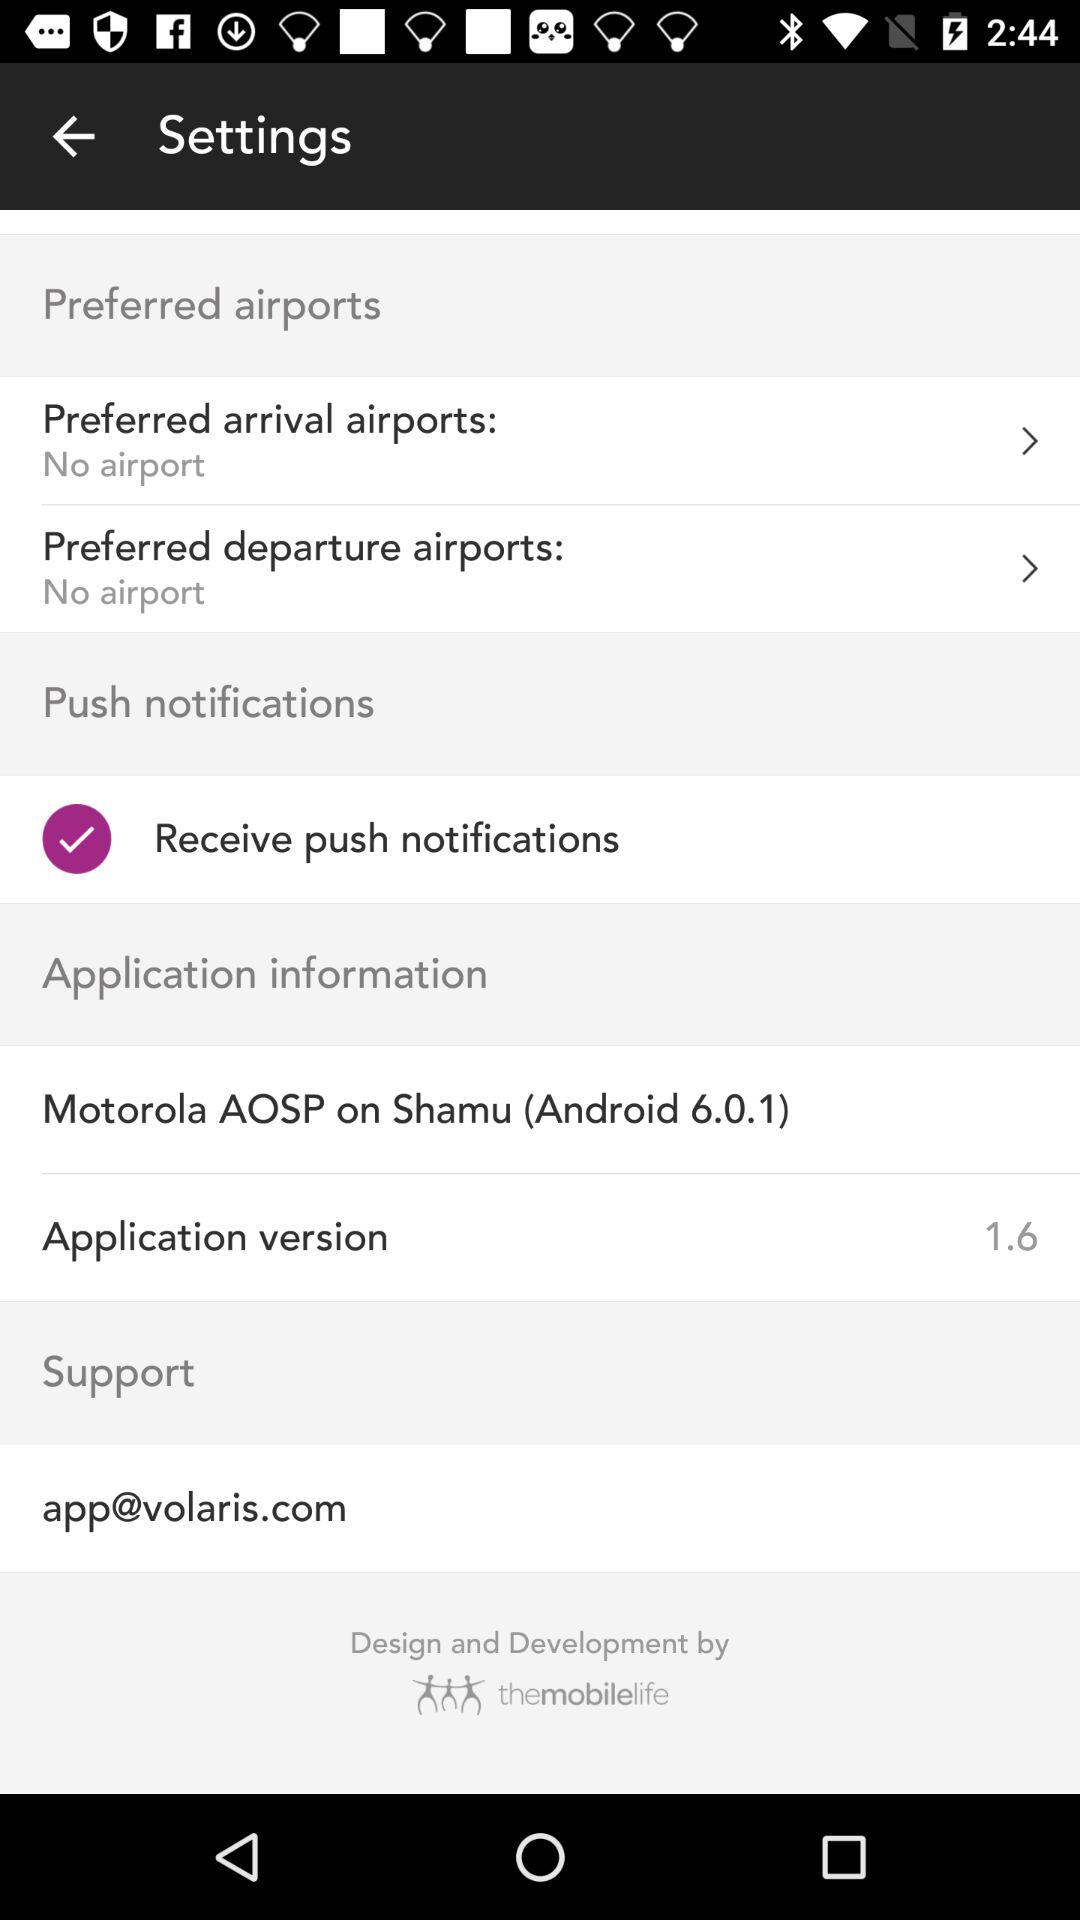Is there any "Preferred arrival airports"? There is no "Preferred arrival airports". 